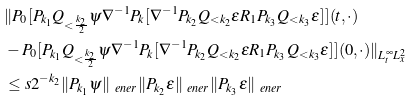Convert formula to latex. <formula><loc_0><loc_0><loc_500><loc_500>& \| P _ { 0 } [ P _ { k _ { 1 } } Q _ { < \frac { k _ { 2 } } { 2 } } \psi \nabla ^ { - 1 } P _ { k } [ \nabla ^ { - 1 } P _ { k _ { 2 } } Q _ { < k _ { 2 } } \epsilon R _ { 1 } P _ { k _ { 3 } } Q _ { < k _ { 3 } } \epsilon ] ] ( t , \cdot ) \\ & - P _ { 0 } [ P _ { k _ { 1 } } Q _ { < \frac { k _ { 2 } } { 2 } } \psi \nabla ^ { - 1 } P _ { k } [ \nabla ^ { - 1 } P _ { k _ { 2 } } Q _ { < k _ { 2 } } \epsilon R _ { 1 } P _ { k _ { 3 } } Q _ { < k _ { 3 } } \epsilon ] ] ( 0 , \cdot ) \| _ { L _ { t } ^ { \infty } L _ { x } ^ { 2 } } \\ & \leq s 2 ^ { - k _ { 2 } } \| P _ { k _ { 1 } } \psi \| _ { \ e n e r } \| P _ { k _ { 2 } } \epsilon \| _ { \ e n e r } \| P _ { k _ { 3 } } \epsilon \| _ { \ e n e r }</formula> 